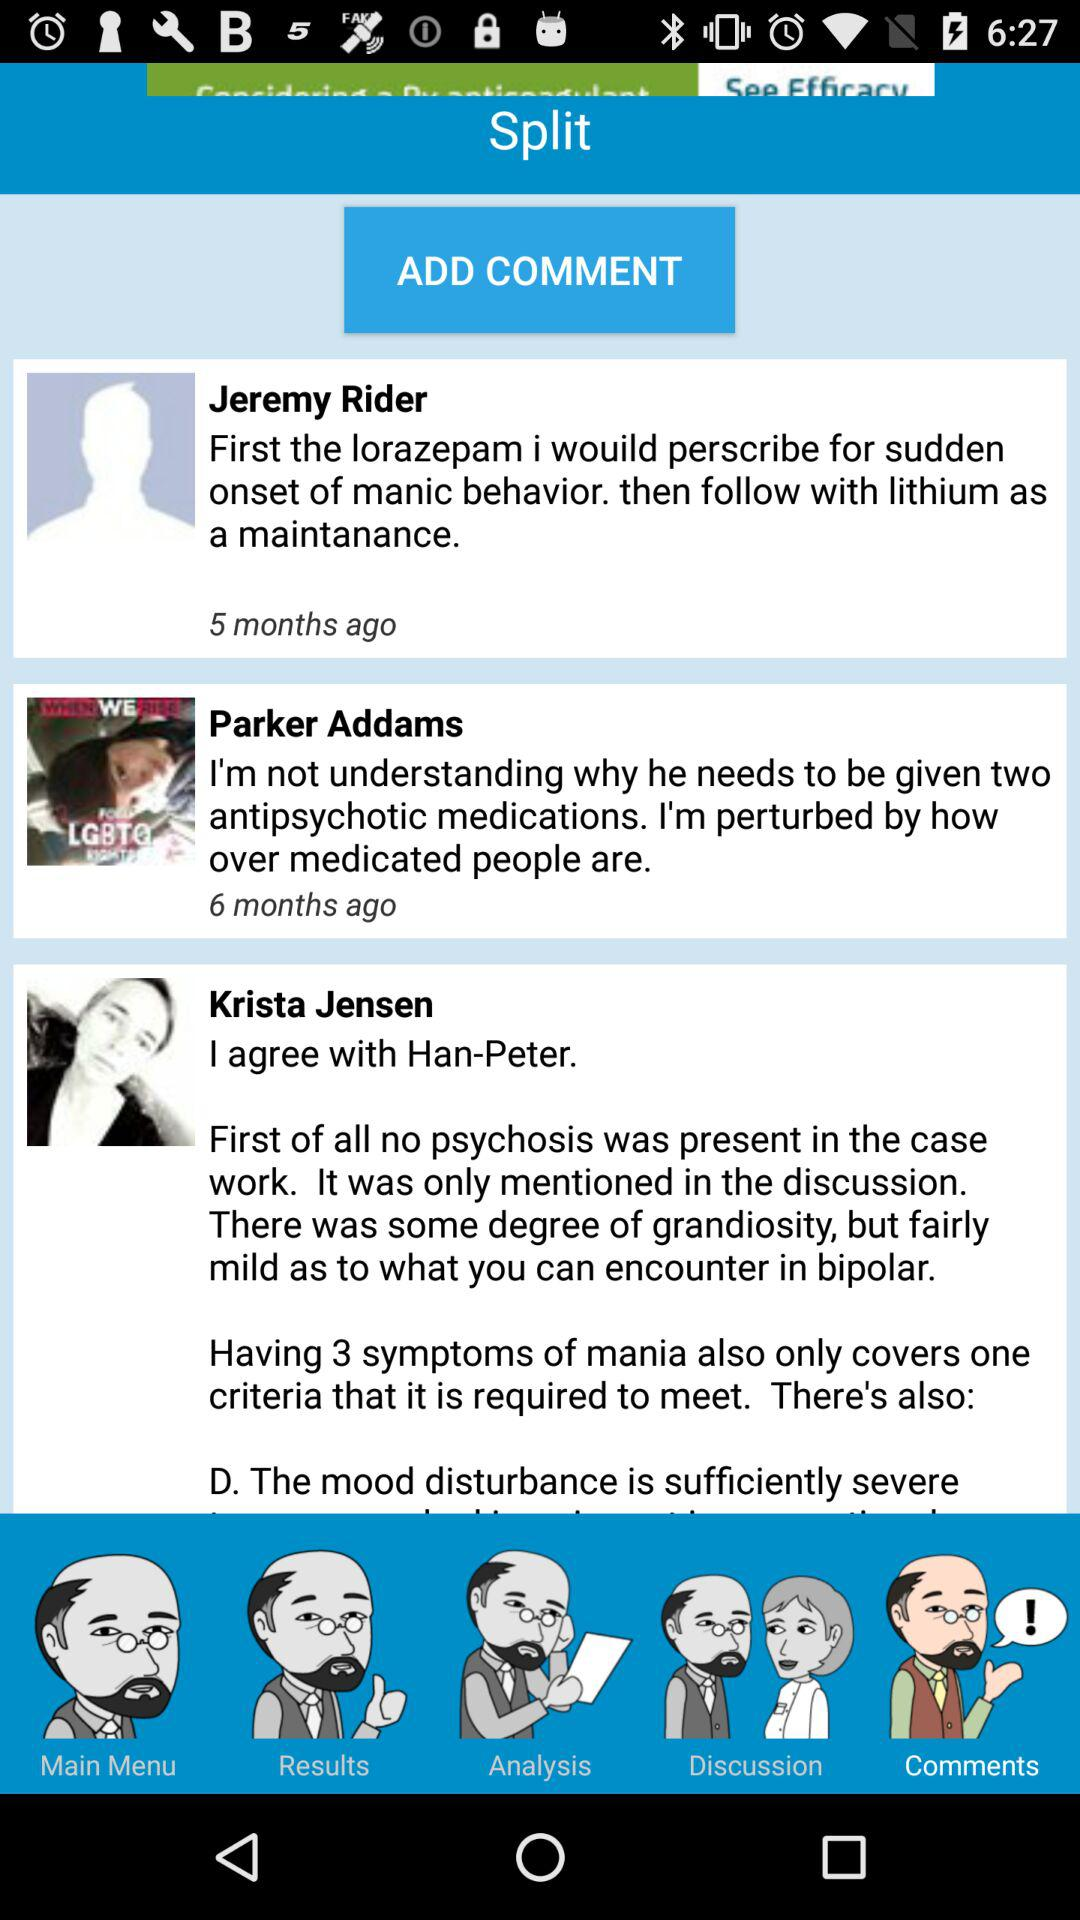How many comments are there on this page?
Answer the question using a single word or phrase. 3 